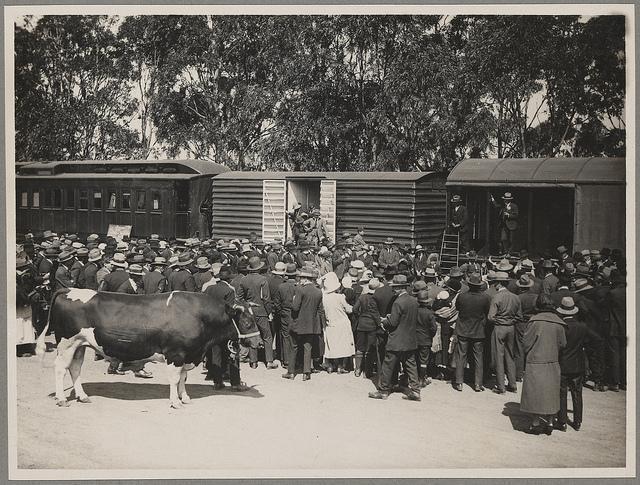How many people are visible?
Give a very brief answer. 7. 